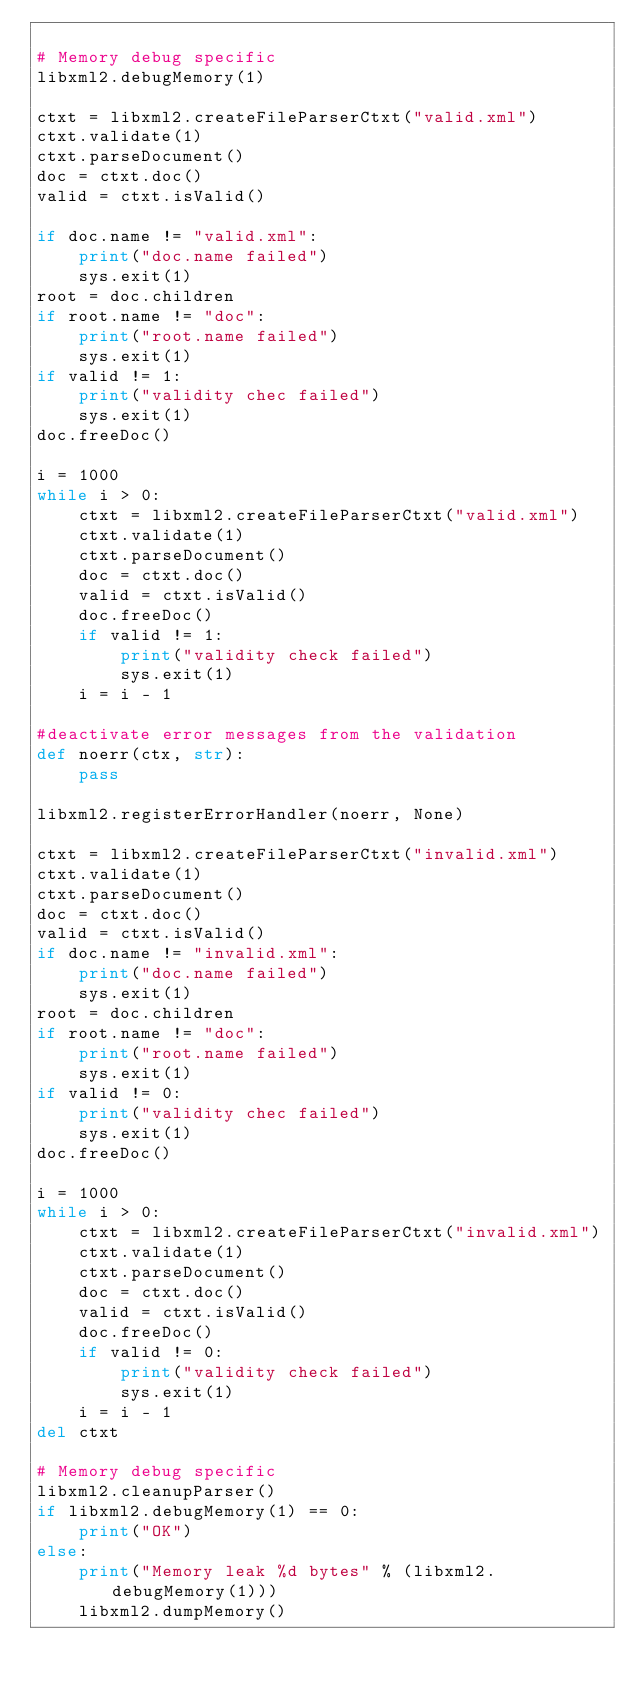Convert code to text. <code><loc_0><loc_0><loc_500><loc_500><_Python_>
# Memory debug specific
libxml2.debugMemory(1)

ctxt = libxml2.createFileParserCtxt("valid.xml")
ctxt.validate(1)
ctxt.parseDocument()
doc = ctxt.doc()
valid = ctxt.isValid()

if doc.name != "valid.xml":
    print("doc.name failed")
    sys.exit(1)
root = doc.children
if root.name != "doc":
    print("root.name failed")
    sys.exit(1)
if valid != 1:
    print("validity chec failed")
    sys.exit(1)
doc.freeDoc()

i = 1000
while i > 0:
    ctxt = libxml2.createFileParserCtxt("valid.xml")
    ctxt.validate(1)
    ctxt.parseDocument()
    doc = ctxt.doc()
    valid = ctxt.isValid()
    doc.freeDoc()
    if valid != 1:
        print("validity check failed")
        sys.exit(1)
    i = i - 1

#deactivate error messages from the validation
def noerr(ctx, str):
    pass

libxml2.registerErrorHandler(noerr, None)

ctxt = libxml2.createFileParserCtxt("invalid.xml")
ctxt.validate(1)
ctxt.parseDocument()
doc = ctxt.doc()
valid = ctxt.isValid()
if doc.name != "invalid.xml":
    print("doc.name failed")
    sys.exit(1)
root = doc.children
if root.name != "doc":
    print("root.name failed")
    sys.exit(1)
if valid != 0:
    print("validity chec failed")
    sys.exit(1)
doc.freeDoc()

i = 1000
while i > 0:
    ctxt = libxml2.createFileParserCtxt("invalid.xml")
    ctxt.validate(1)
    ctxt.parseDocument()
    doc = ctxt.doc()
    valid = ctxt.isValid()
    doc.freeDoc()
    if valid != 0:
        print("validity check failed")
        sys.exit(1)
    i = i - 1
del ctxt

# Memory debug specific
libxml2.cleanupParser()
if libxml2.debugMemory(1) == 0:
    print("OK")
else:
    print("Memory leak %d bytes" % (libxml2.debugMemory(1)))
    libxml2.dumpMemory()
</code> 